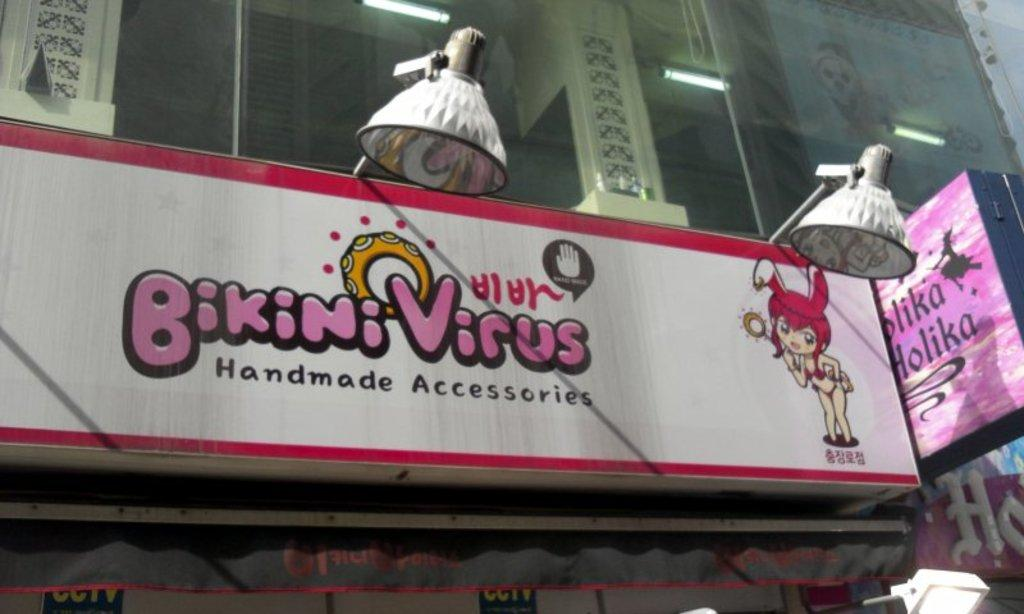What is the main object in the center of the image? There is a glass in the center of the image. What type of lighting is present in the image? There are lights and hanging lamps in the image. Are there any text-based elements in the image? Yes, there are boards with text in the image. Can you describe any other objects visible in the image? There are a few other objects in the image, but their specific details are not mentioned in the provided facts. What type of slope can be seen in the image? There is no slope present in the image. Are there any stockings visible in the image? There is no mention of stockings in the provided facts, so it cannot be determined if they are present in the image. 